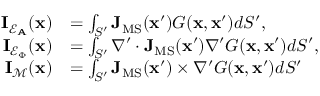Convert formula to latex. <formula><loc_0><loc_0><loc_500><loc_500>\begin{array} { r l } { I _ { \mathcal { E } _ { A } } ( x ) } & { = \int _ { S ^ { \prime } } J _ { M S } ( x ^ { \prime } ) G ( x , x ^ { \prime } ) d S ^ { \prime } , } \\ { I _ { \mathcal { E } _ { \Phi } } ( x ) } & { = \int _ { S ^ { \prime } } \nabla ^ { \prime } \cdot J _ { M S } ( x ^ { \prime } ) \nabla ^ { \prime } G ( x , x ^ { \prime } ) d S ^ { \prime } , } \\ { I _ { \mathcal { M } } ( x ) } & { = \int _ { S ^ { \prime } } J _ { M S } ( x ^ { \prime } ) \times \nabla ^ { \prime } G ( x , x ^ { \prime } ) d S ^ { \prime } } \end{array}</formula> 